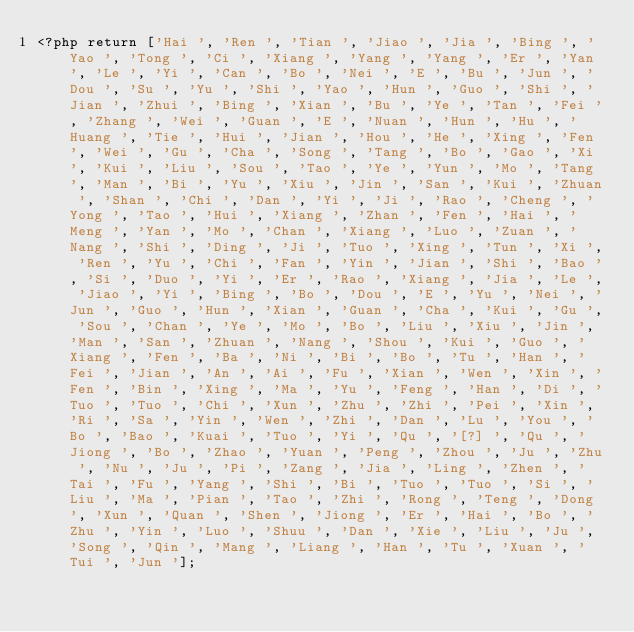Convert code to text. <code><loc_0><loc_0><loc_500><loc_500><_PHP_><?php return ['Hai ', 'Ren ', 'Tian ', 'Jiao ', 'Jia ', 'Bing ', 'Yao ', 'Tong ', 'Ci ', 'Xiang ', 'Yang ', 'Yang ', 'Er ', 'Yan ', 'Le ', 'Yi ', 'Can ', 'Bo ', 'Nei ', 'E ', 'Bu ', 'Jun ', 'Dou ', 'Su ', 'Yu ', 'Shi ', 'Yao ', 'Hun ', 'Guo ', 'Shi ', 'Jian ', 'Zhui ', 'Bing ', 'Xian ', 'Bu ', 'Ye ', 'Tan ', 'Fei ', 'Zhang ', 'Wei ', 'Guan ', 'E ', 'Nuan ', 'Hun ', 'Hu ', 'Huang ', 'Tie ', 'Hui ', 'Jian ', 'Hou ', 'He ', 'Xing ', 'Fen ', 'Wei ', 'Gu ', 'Cha ', 'Song ', 'Tang ', 'Bo ', 'Gao ', 'Xi ', 'Kui ', 'Liu ', 'Sou ', 'Tao ', 'Ye ', 'Yun ', 'Mo ', 'Tang ', 'Man ', 'Bi ', 'Yu ', 'Xiu ', 'Jin ', 'San ', 'Kui ', 'Zhuan ', 'Shan ', 'Chi ', 'Dan ', 'Yi ', 'Ji ', 'Rao ', 'Cheng ', 'Yong ', 'Tao ', 'Hui ', 'Xiang ', 'Zhan ', 'Fen ', 'Hai ', 'Meng ', 'Yan ', 'Mo ', 'Chan ', 'Xiang ', 'Luo ', 'Zuan ', 'Nang ', 'Shi ', 'Ding ', 'Ji ', 'Tuo ', 'Xing ', 'Tun ', 'Xi ', 'Ren ', 'Yu ', 'Chi ', 'Fan ', 'Yin ', 'Jian ', 'Shi ', 'Bao ', 'Si ', 'Duo ', 'Yi ', 'Er ', 'Rao ', 'Xiang ', 'Jia ', 'Le ', 'Jiao ', 'Yi ', 'Bing ', 'Bo ', 'Dou ', 'E ', 'Yu ', 'Nei ', 'Jun ', 'Guo ', 'Hun ', 'Xian ', 'Guan ', 'Cha ', 'Kui ', 'Gu ', 'Sou ', 'Chan ', 'Ye ', 'Mo ', 'Bo ', 'Liu ', 'Xiu ', 'Jin ', 'Man ', 'San ', 'Zhuan ', 'Nang ', 'Shou ', 'Kui ', 'Guo ', 'Xiang ', 'Fen ', 'Ba ', 'Ni ', 'Bi ', 'Bo ', 'Tu ', 'Han ', 'Fei ', 'Jian ', 'An ', 'Ai ', 'Fu ', 'Xian ', 'Wen ', 'Xin ', 'Fen ', 'Bin ', 'Xing ', 'Ma ', 'Yu ', 'Feng ', 'Han ', 'Di ', 'Tuo ', 'Tuo ', 'Chi ', 'Xun ', 'Zhu ', 'Zhi ', 'Pei ', 'Xin ', 'Ri ', 'Sa ', 'Yin ', 'Wen ', 'Zhi ', 'Dan ', 'Lu ', 'You ', 'Bo ', 'Bao ', 'Kuai ', 'Tuo ', 'Yi ', 'Qu ', '[?] ', 'Qu ', 'Jiong ', 'Bo ', 'Zhao ', 'Yuan ', 'Peng ', 'Zhou ', 'Ju ', 'Zhu ', 'Nu ', 'Ju ', 'Pi ', 'Zang ', 'Jia ', 'Ling ', 'Zhen ', 'Tai ', 'Fu ', 'Yang ', 'Shi ', 'Bi ', 'Tuo ', 'Tuo ', 'Si ', 'Liu ', 'Ma ', 'Pian ', 'Tao ', 'Zhi ', 'Rong ', 'Teng ', 'Dong ', 'Xun ', 'Quan ', 'Shen ', 'Jiong ', 'Er ', 'Hai ', 'Bo ', 'Zhu ', 'Yin ', 'Luo ', 'Shuu ', 'Dan ', 'Xie ', 'Liu ', 'Ju ', 'Song ', 'Qin ', 'Mang ', 'Liang ', 'Han ', 'Tu ', 'Xuan ', 'Tui ', 'Jun '];
</code> 